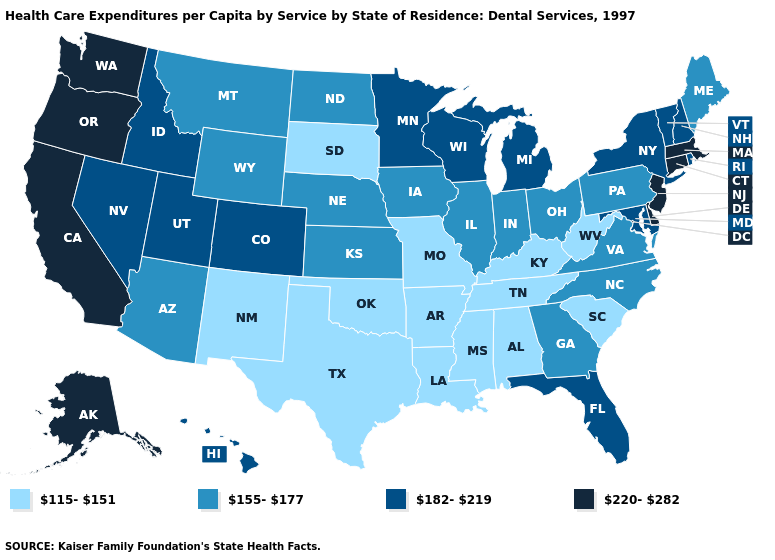Does New Mexico have the lowest value in the USA?
Quick response, please. Yes. What is the value of Idaho?
Answer briefly. 182-219. Among the states that border Georgia , does Florida have the lowest value?
Answer briefly. No. Does West Virginia have a higher value than Delaware?
Short answer required. No. What is the value of Delaware?
Be succinct. 220-282. What is the value of Mississippi?
Be succinct. 115-151. Which states have the lowest value in the West?
Short answer required. New Mexico. Which states have the lowest value in the USA?
Concise answer only. Alabama, Arkansas, Kentucky, Louisiana, Mississippi, Missouri, New Mexico, Oklahoma, South Carolina, South Dakota, Tennessee, Texas, West Virginia. What is the value of Iowa?
Quick response, please. 155-177. Does Delaware have the same value as Alaska?
Be succinct. Yes. What is the value of Wisconsin?
Give a very brief answer. 182-219. What is the lowest value in the MidWest?
Keep it brief. 115-151. Does New Hampshire have the highest value in the USA?
Quick response, please. No. What is the value of Connecticut?
Concise answer only. 220-282. Which states have the lowest value in the USA?
Give a very brief answer. Alabama, Arkansas, Kentucky, Louisiana, Mississippi, Missouri, New Mexico, Oklahoma, South Carolina, South Dakota, Tennessee, Texas, West Virginia. 